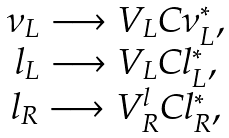<formula> <loc_0><loc_0><loc_500><loc_500>\begin{array} { c } \nu _ { L } \longrightarrow V _ { L } C { \nu ^ { * } _ { L } } , \\ l _ { L } \longrightarrow V _ { L } C { l ^ { * } _ { L } } , \\ l _ { R } \longrightarrow { V ^ { l } _ { R } } C { l ^ { * } _ { R } } , \end{array}</formula> 